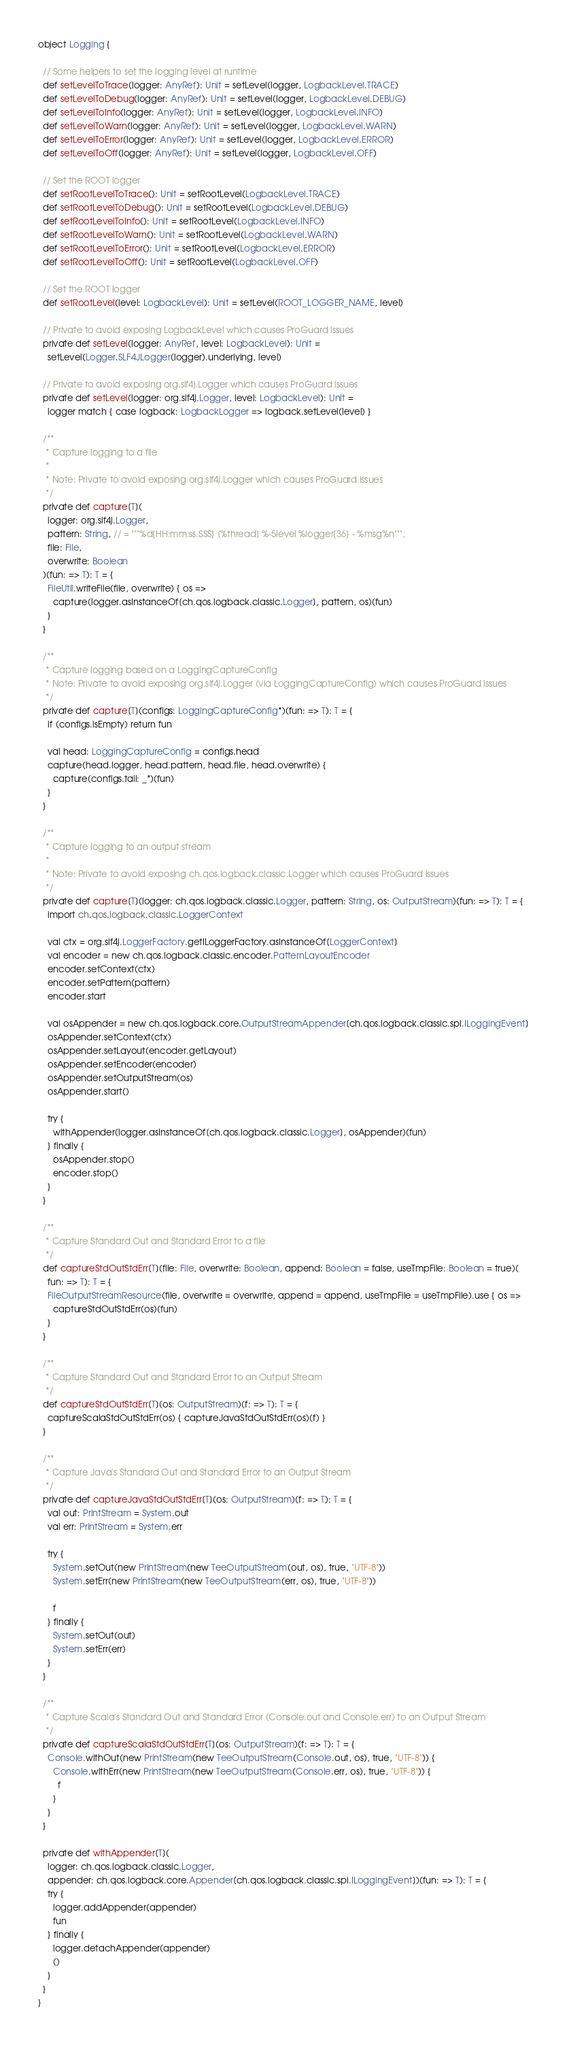<code> <loc_0><loc_0><loc_500><loc_500><_Scala_>object Logging {

  // Some helpers to set the logging level at runtime
  def setLevelToTrace(logger: AnyRef): Unit = setLevel(logger, LogbackLevel.TRACE)
  def setLevelToDebug(logger: AnyRef): Unit = setLevel(logger, LogbackLevel.DEBUG)
  def setLevelToInfo(logger: AnyRef): Unit = setLevel(logger, LogbackLevel.INFO)
  def setLevelToWarn(logger: AnyRef): Unit = setLevel(logger, LogbackLevel.WARN)
  def setLevelToError(logger: AnyRef): Unit = setLevel(logger, LogbackLevel.ERROR)
  def setLevelToOff(logger: AnyRef): Unit = setLevel(logger, LogbackLevel.OFF)

  // Set the ROOT logger
  def setRootLevelToTrace(): Unit = setRootLevel(LogbackLevel.TRACE)
  def setRootLevelToDebug(): Unit = setRootLevel(LogbackLevel.DEBUG)
  def setRootLevelToInfo(): Unit = setRootLevel(LogbackLevel.INFO)
  def setRootLevelToWarn(): Unit = setRootLevel(LogbackLevel.WARN)
  def setRootLevelToError(): Unit = setRootLevel(LogbackLevel.ERROR)
  def setRootLevelToOff(): Unit = setRootLevel(LogbackLevel.OFF)

  // Set the ROOT logger
  def setRootLevel(level: LogbackLevel): Unit = setLevel(ROOT_LOGGER_NAME, level)

  // Private to avoid exposing LogbackLevel which causes ProGuard issues
  private def setLevel(logger: AnyRef, level: LogbackLevel): Unit =
    setLevel(Logger.SLF4JLogger(logger).underlying, level)

  // Private to avoid exposing org.slf4j.Logger which causes ProGuard issues
  private def setLevel(logger: org.slf4j.Logger, level: LogbackLevel): Unit =
    logger match { case logback: LogbackLogger => logback.setLevel(level) }

  /**
   * Capture logging to a file
   *
   * Note: Private to avoid exposing org.slf4j.Logger which causes ProGuard issues
   */
  private def capture[T](
    logger: org.slf4j.Logger,
    pattern: String, // = """%d{HH:mm:ss.SSS} [%thread] %-5level %logger{36} - %msg%n""",
    file: File,
    overwrite: Boolean
  )(fun: => T): T = {
    FileUtil.writeFile(file, overwrite) { os =>
      capture(logger.asInstanceOf[ch.qos.logback.classic.Logger], pattern, os)(fun)
    }
  }

  /**
   * Capture logging based on a LoggingCaptureConfig
   * Note: Private to avoid exposing org.slf4j.Logger (via LoggingCaptureConfig) which causes ProGuard issues
   */
  private def capture[T](configs: LoggingCaptureConfig*)(fun: => T): T = {
    if (configs.isEmpty) return fun

    val head: LoggingCaptureConfig = configs.head
    capture(head.logger, head.pattern, head.file, head.overwrite) {
      capture(configs.tail: _*)(fun)
    }
  }

  /**
   * Capture logging to an output stream
   *
   * Note: Private to avoid exposing ch.qos.logback.classic.Logger which causes ProGuard issues
   */
  private def capture[T](logger: ch.qos.logback.classic.Logger, pattern: String, os: OutputStream)(fun: => T): T = {
    import ch.qos.logback.classic.LoggerContext

    val ctx = org.slf4j.LoggerFactory.getILoggerFactory.asInstanceOf[LoggerContext]
    val encoder = new ch.qos.logback.classic.encoder.PatternLayoutEncoder
    encoder.setContext(ctx)
    encoder.setPattern(pattern)
    encoder.start

    val osAppender = new ch.qos.logback.core.OutputStreamAppender[ch.qos.logback.classic.spi.ILoggingEvent]
    osAppender.setContext(ctx)
    osAppender.setLayout(encoder.getLayout)
    osAppender.setEncoder(encoder)
    osAppender.setOutputStream(os)
    osAppender.start()

    try {
      withAppender(logger.asInstanceOf[ch.qos.logback.classic.Logger], osAppender)(fun)
    } finally {
      osAppender.stop()
      encoder.stop()
    }
  }

  /**
   * Capture Standard Out and Standard Error to a file
   */
  def captureStdOutStdErr[T](file: File, overwrite: Boolean, append: Boolean = false, useTmpFile: Boolean = true)(
    fun: => T): T = {
    FileOutputStreamResource(file, overwrite = overwrite, append = append, useTmpFile = useTmpFile).use { os =>
      captureStdOutStdErr(os)(fun)
    }
  }

  /**
   * Capture Standard Out and Standard Error to an Output Stream
   */
  def captureStdOutStdErr[T](os: OutputStream)(f: => T): T = {
    captureScalaStdOutStdErr(os) { captureJavaStdOutStdErr(os)(f) }
  }

  /**
   * Capture Java's Standard Out and Standard Error to an Output Stream
   */
  private def captureJavaStdOutStdErr[T](os: OutputStream)(f: => T): T = {
    val out: PrintStream = System.out
    val err: PrintStream = System.err

    try {
      System.setOut(new PrintStream(new TeeOutputStream(out, os), true, "UTF-8"))
      System.setErr(new PrintStream(new TeeOutputStream(err, os), true, "UTF-8"))

      f
    } finally {
      System.setOut(out)
      System.setErr(err)
    }
  }

  /**
   * Capture Scala's Standard Out and Standard Error (Console.out and Console.err) to an Output Stream
   */
  private def captureScalaStdOutStdErr[T](os: OutputStream)(f: => T): T = {
    Console.withOut(new PrintStream(new TeeOutputStream(Console.out, os), true, "UTF-8")) {
      Console.withErr(new PrintStream(new TeeOutputStream(Console.err, os), true, "UTF-8")) {
        f
      }
    }
  }

  private def withAppender[T](
    logger: ch.qos.logback.classic.Logger,
    appender: ch.qos.logback.core.Appender[ch.qos.logback.classic.spi.ILoggingEvent])(fun: => T): T = {
    try {
      logger.addAppender(appender)
      fun
    } finally {
      logger.detachAppender(appender)
      ()
    }
  }
}
</code> 